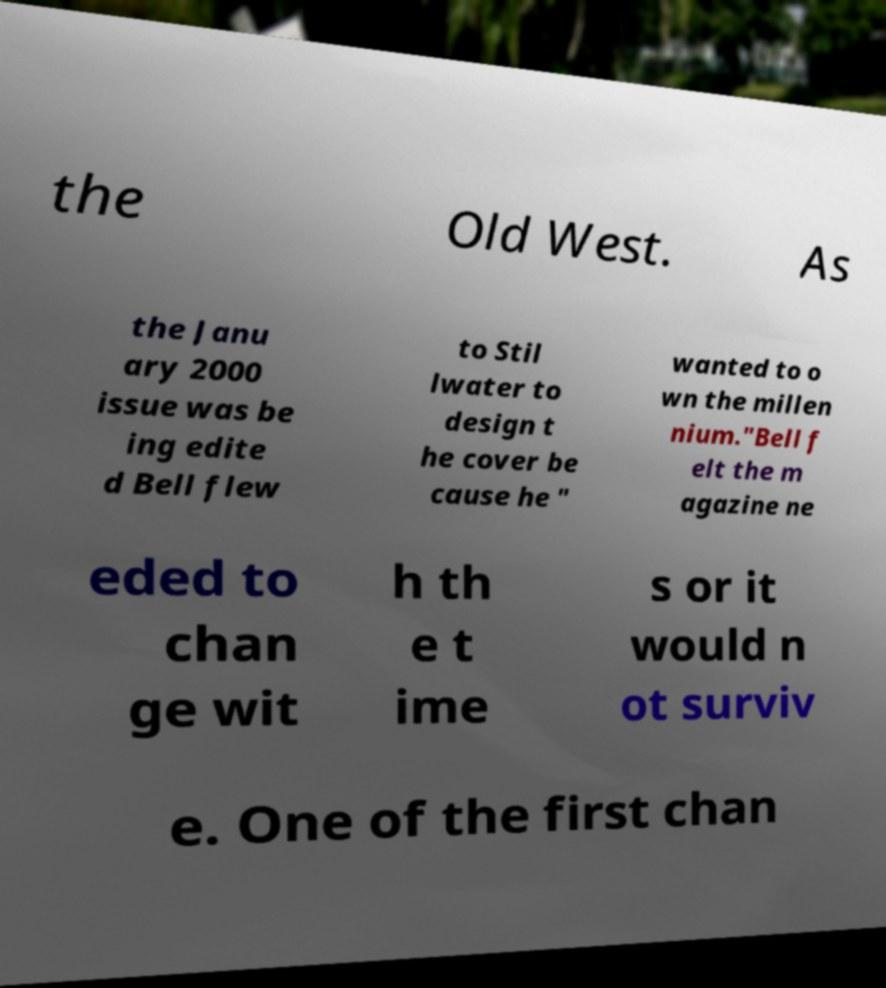For documentation purposes, I need the text within this image transcribed. Could you provide that? the Old West. As the Janu ary 2000 issue was be ing edite d Bell flew to Stil lwater to design t he cover be cause he " wanted to o wn the millen nium."Bell f elt the m agazine ne eded to chan ge wit h th e t ime s or it would n ot surviv e. One of the first chan 